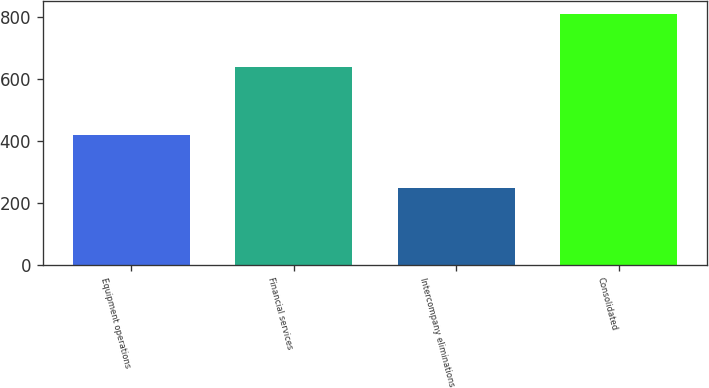Convert chart. <chart><loc_0><loc_0><loc_500><loc_500><bar_chart><fcel>Equipment operations<fcel>Financial services<fcel>Intercompany eliminations<fcel>Consolidated<nl><fcel>420<fcel>638<fcel>248<fcel>810<nl></chart> 